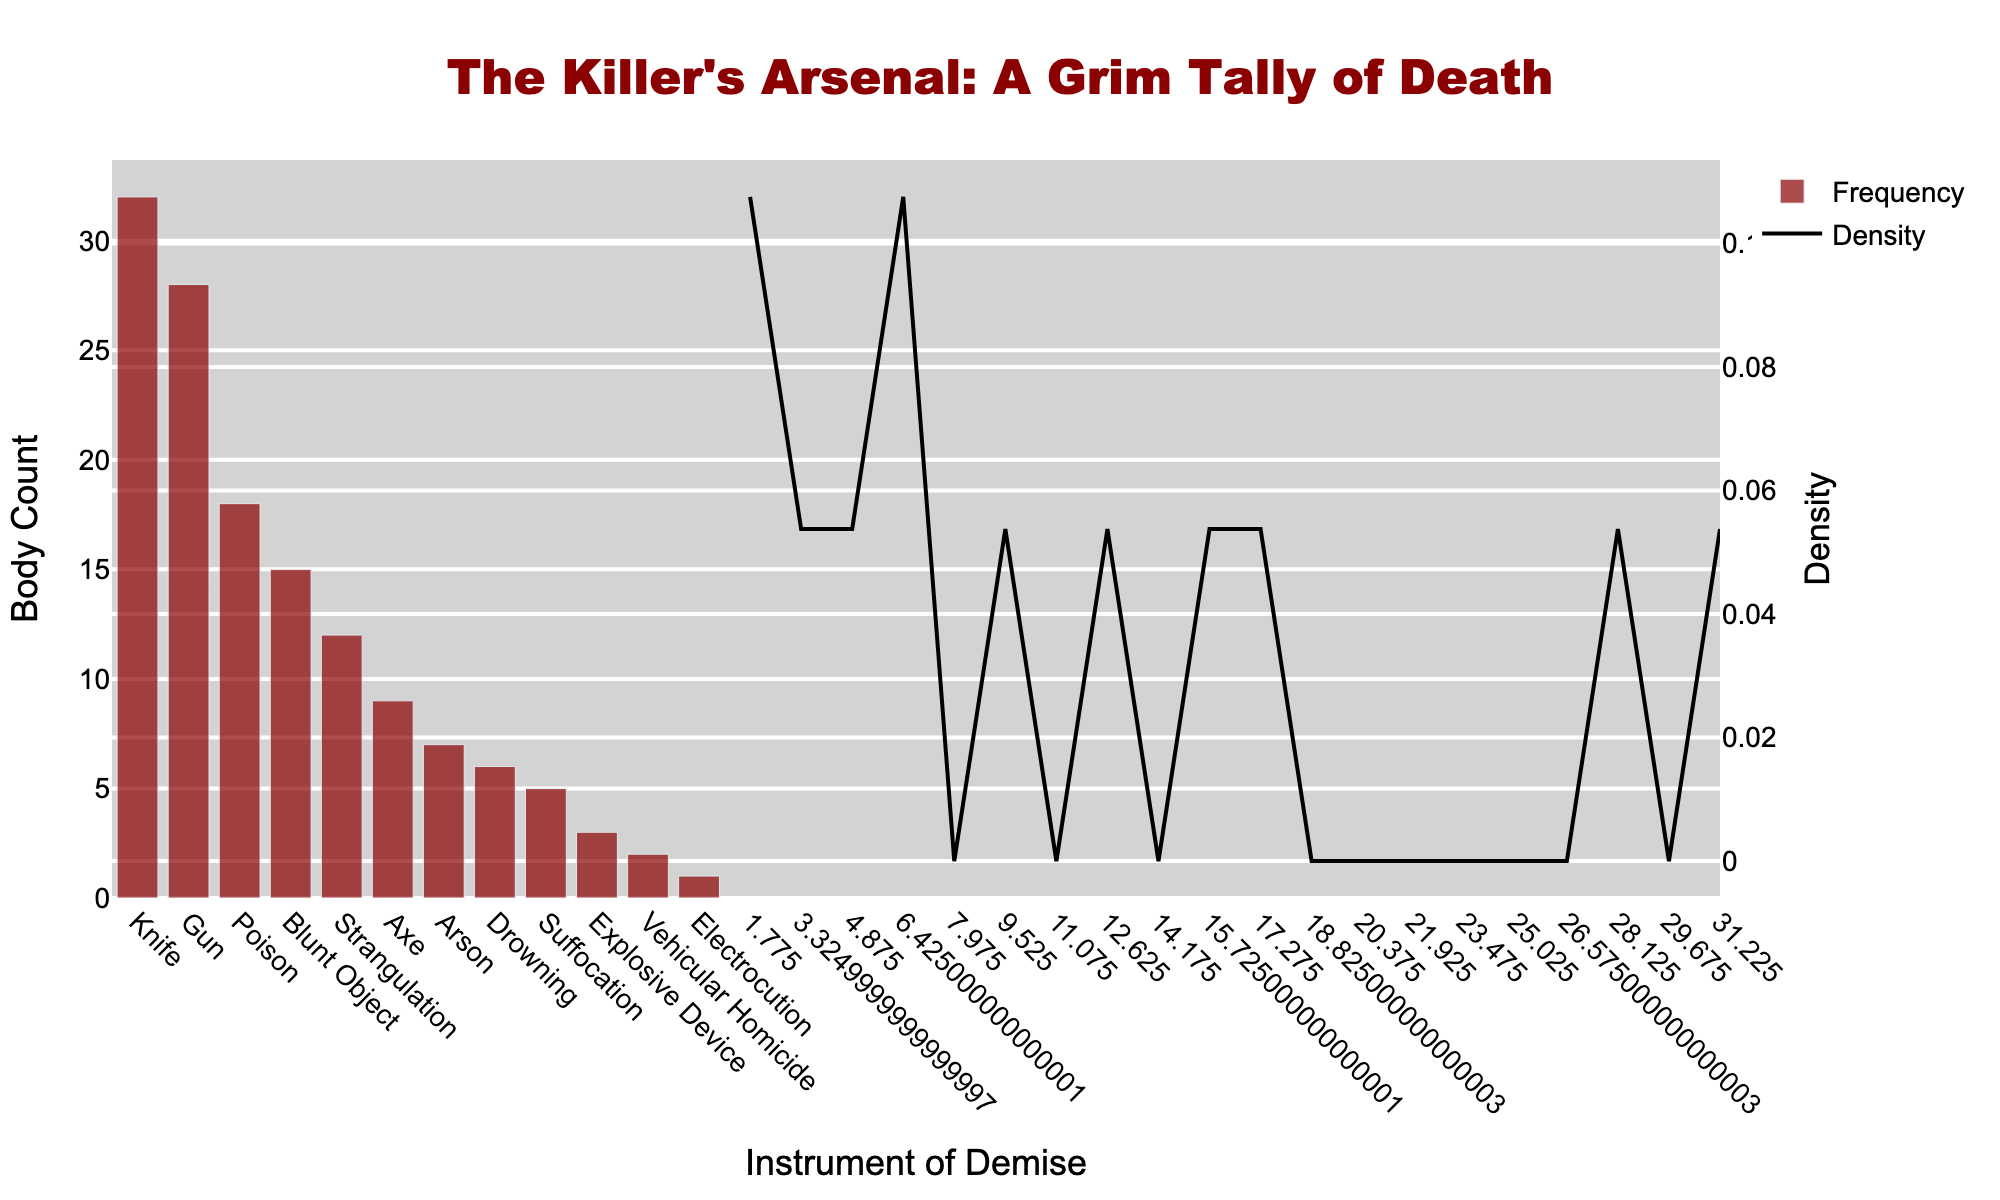What is the title of the histogram? The title of the histogram is found at the top center of the figure. It states the purpose or theme of the visualized data, giving context to what the viewer is looking at.
Answer: "The Killer's Arsenal: A Grim Tally of Death" What weapon has the highest frequency? Look at the height of the bars in the histogram. The weapon with the tallest bar represents the highest frequency.
Answer: Knife How many weapons have a frequency of less than 10? By analyzing the height of the bars and the tick values on the y-axis, count the number of bars that are below the tick value representing 10.
Answer: 5 Which is more common: Gun or Poison? Compare the height of the bar representing Gun with the height of the bar representing Poison. The taller bar indicates the more common weapon.
Answer: Gun What is the sum of the frequencies of the top three most common weapons? Identify the top three bars in terms of height, which correspond to the most common weapons and sum their frequencies (Knife: 32, Gun: 28, Poison: 18).
Answer: 78 What is the color of the bars in the histogram? The color of the bars is visually apparent and can be identified directly by looking at the bars in the histogram.
Answer: Dark red How many weapons have the same frequency as Explosive Device? Find the bar labeled Explosive Device and note its frequency, then count other bars with the same frequency (3).
Answer: 0 What is the difference in frequency between the most common and the least common weapon? Identify the highest and lowest bars in the histogram and subtract their frequencies (Most common: Knife with 32, Least common: Electrocution with 1).
Answer: 31 At what point does the KDE (density curve) peak? Observe the KDE (density curve), which is overlayed on the histogram, and identify the x-axis value where it reaches its highest point.
Answer: Near 5-10 frequency How does the frequency of Blunt Object compare to that of Strangulation? Look at the bars representing Blunt Object and Strangulation and compare their heights. Blunt Object has a frequency of 15 while Strangulation has a frequency of 12.
Answer: Blunt Object is higher 